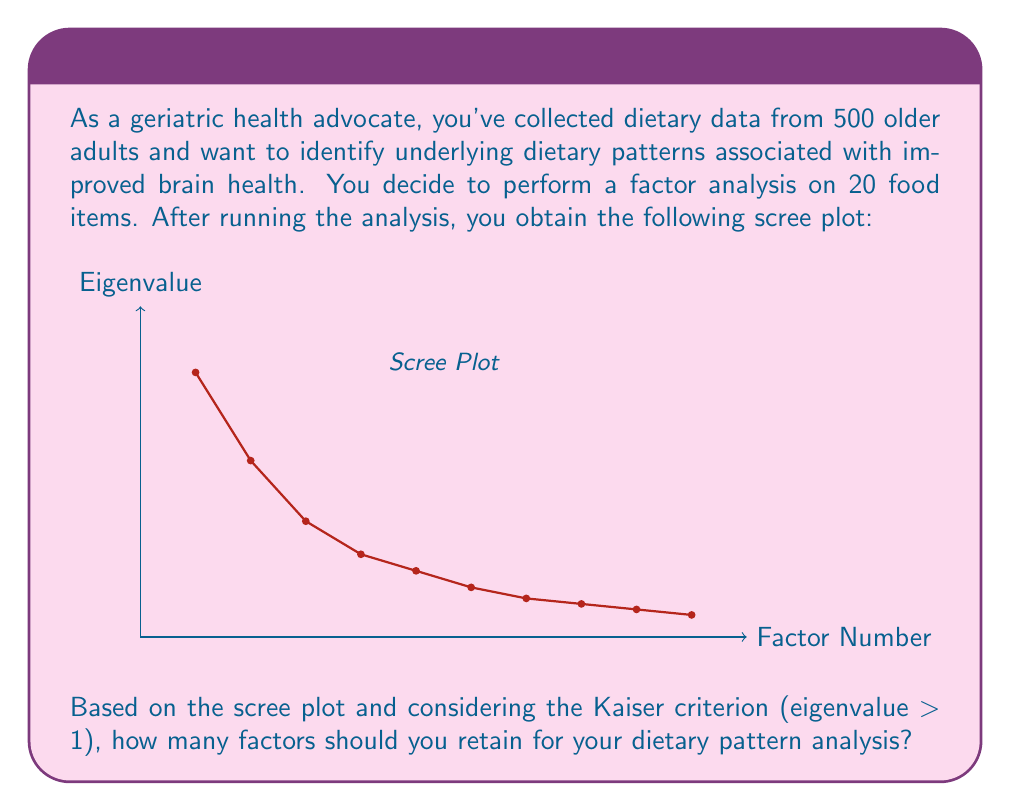Teach me how to tackle this problem. To determine the number of factors to retain in factor analysis, we can use two common criteria:

1. Kaiser criterion: Retain factors with eigenvalues greater than 1.
2. Scree plot analysis: Look for the "elbow" point where the curve levels off.

Let's analyze the scree plot step-by-step:

1. Identify eigenvalues > 1:
   Factor 1: 4.8 > 1
   Factor 2: 3.2 > 1
   Factor 3: 2.1 > 1
   Factor 4: 1.5 > 1
   Factor 5: 1.2 > 1
   Factor 6: 0.9 < 1 (stop here)

2. Count factors with eigenvalues > 1:
   There are 5 factors that meet this criterion.

3. Examine the scree plot:
   The "elbow" or point of inflection appears to be around factor 5, where the curve starts to level off more dramatically.

4. Combine both criteria:
   Both the Kaiser criterion and the scree plot analysis suggest retaining 5 factors.

Therefore, based on this analysis, you should retain 5 factors for your dietary pattern analysis. These 5 factors will likely represent the main underlying dietary patterns associated with improved brain health in older adults.
Answer: 5 factors 